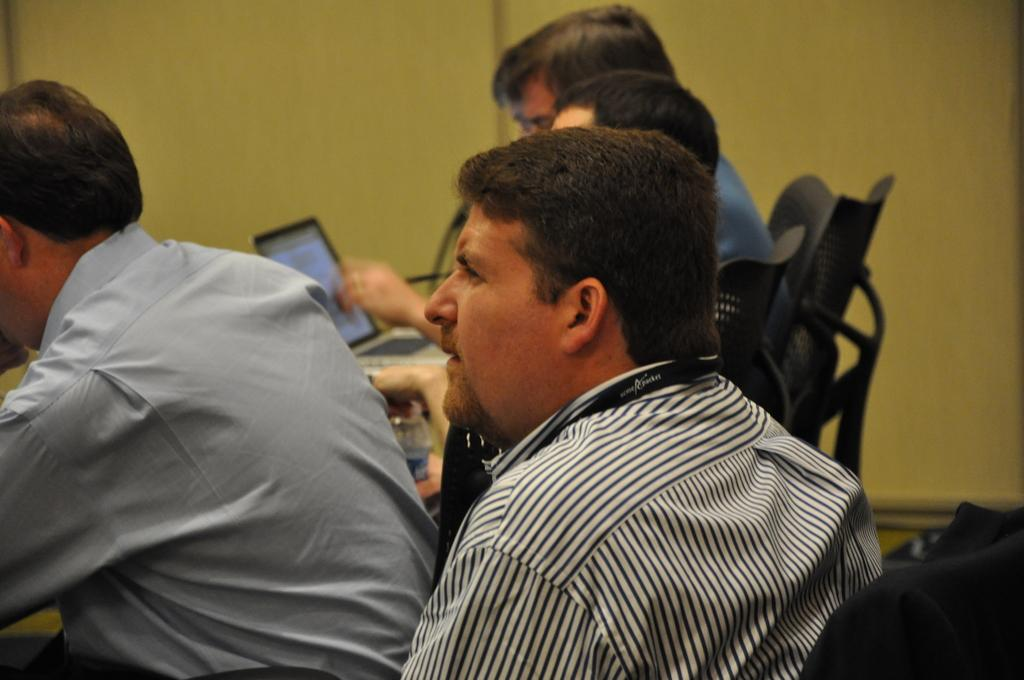How many people are sitting in the image? There are four persons sitting on chairs in the image. What electronic device can be seen in the image? There is a laptop in the image. What other object is visible in the image? There is a bottle in the image. What can be seen in the background of the image? There is a wall in the background of the image. What type of wood is used to make the chairs in the image? There is no information about the material of the chairs in the image, so we cannot determine the type of wood used. 